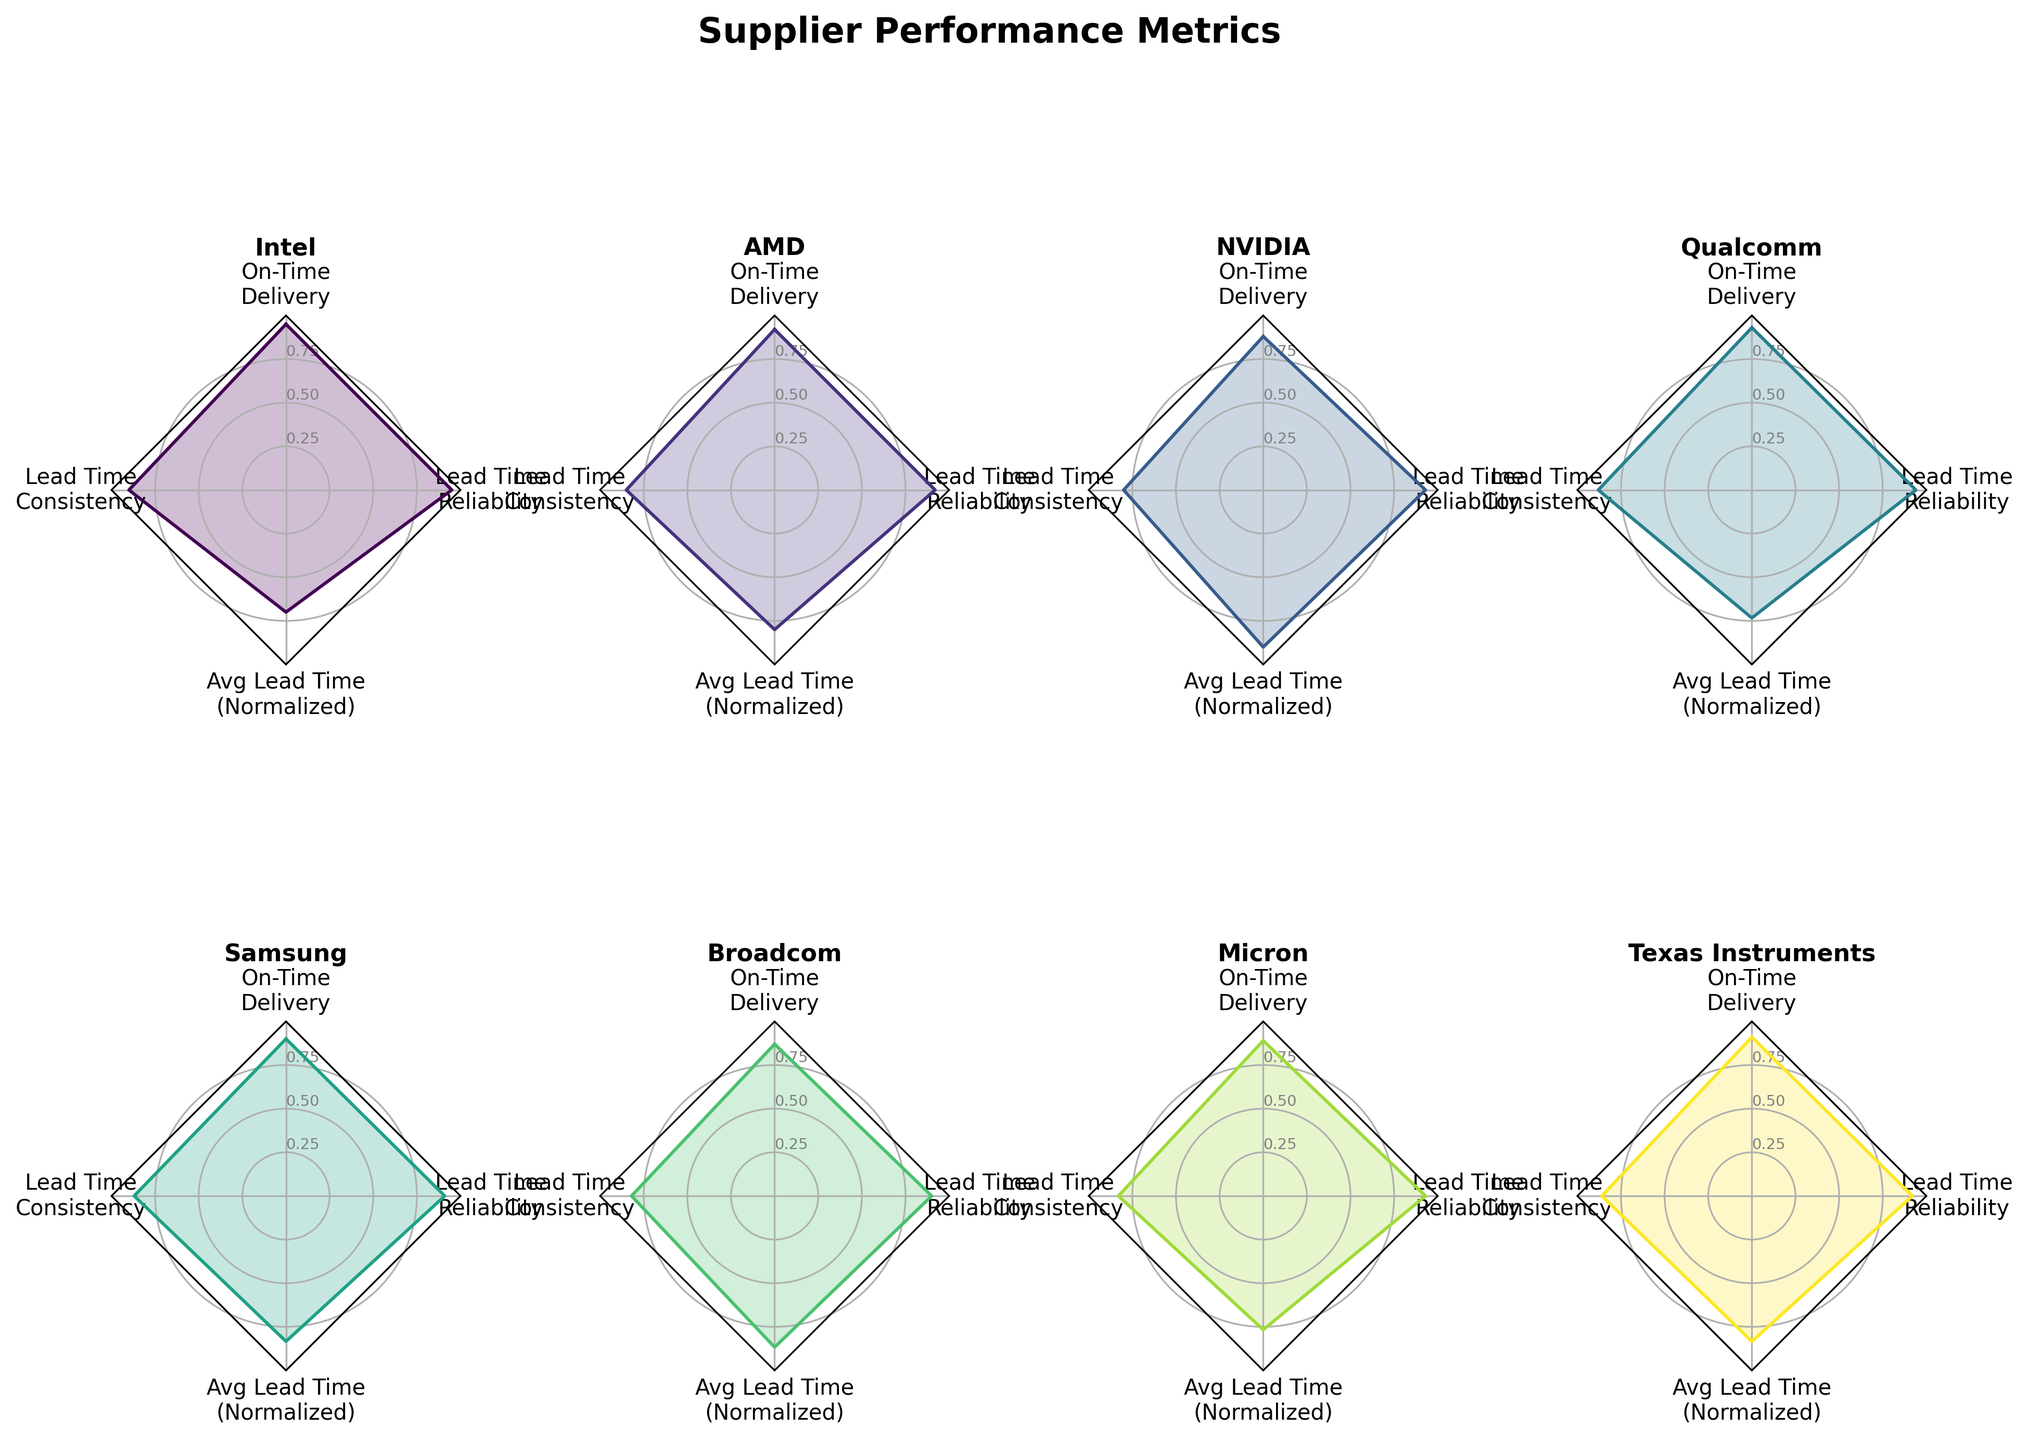What is the on-time delivery rate of Intel? By looking at the radar chart for Intel, the on-time delivery section should match the value specifically for Intel.
Answer: 0.95 How does AMD compare to NVIDIA in terms of lead time consistency? Observing the radar charts of both AMD and NVIDIA, look at the lead time consistency scores to see which one is higher.
Answer: AMD has a better lead time consistency than NVIDIA Which supplier has the highest average lead time? Check the "Average Lead Time (Normalized)" section in each supplier’s radar chart and find which supplier has the highest value.
Answer: NVIDIA Between Qualcomm and Samsung, which one has better lead time reliability? Compare the lead time reliability (1 - Variability in Lead Time) on the radar charts of Qualcomm and Samsung and see which value is higher.
Answer: Qualcomm What is the relationship between on-time delivery rate and lead time consistency for Broadcom? Identify the on-time delivery rate and lead time consistency values on Broadcom’s radar chart. Evaluate if there seems to be any correlation.
Answer: Broadcom has an on-time delivery rate of 0.87 and lead time consistency of 0.82, indicating a moderate relationship Which supplier offers the most consistent lead time? Look at the lead time consistency values for all suppliers and determine which one is the highest.
Answer: Intel Compare the average lead time (normalized) between Micron and Texas Instruments. Examine the "Avg Lead Time (Normalized)" section for both Micron and Texas Instruments on their radar charts and compare the values.
Answer: Micron has a lower normalized average lead time How do Samsung and Broadcom compare across all metrics? Compare each metric across the radar charts of Samsung and Broadcom to understand their relative performance in on-time delivery rate, lead time consistency, average lead time (normalized), and lead time reliability.
Answer: Samsung generally performs better in lead time consistency and on-time delivery, while Broadcom has slightly better lead time reliability What can be inferred about the overall performance of Qualcomm based on its radar chart? Examine all four metrics on Qualcomm's radar chart: on-time delivery rate, lead time consistency, average lead time (normalized), and lead time reliability. Summarize their performance across all areas.
Answer: Qualcomm shows strong on-time delivery and good lead time consistency and reliability with a moderate normalized average lead time 